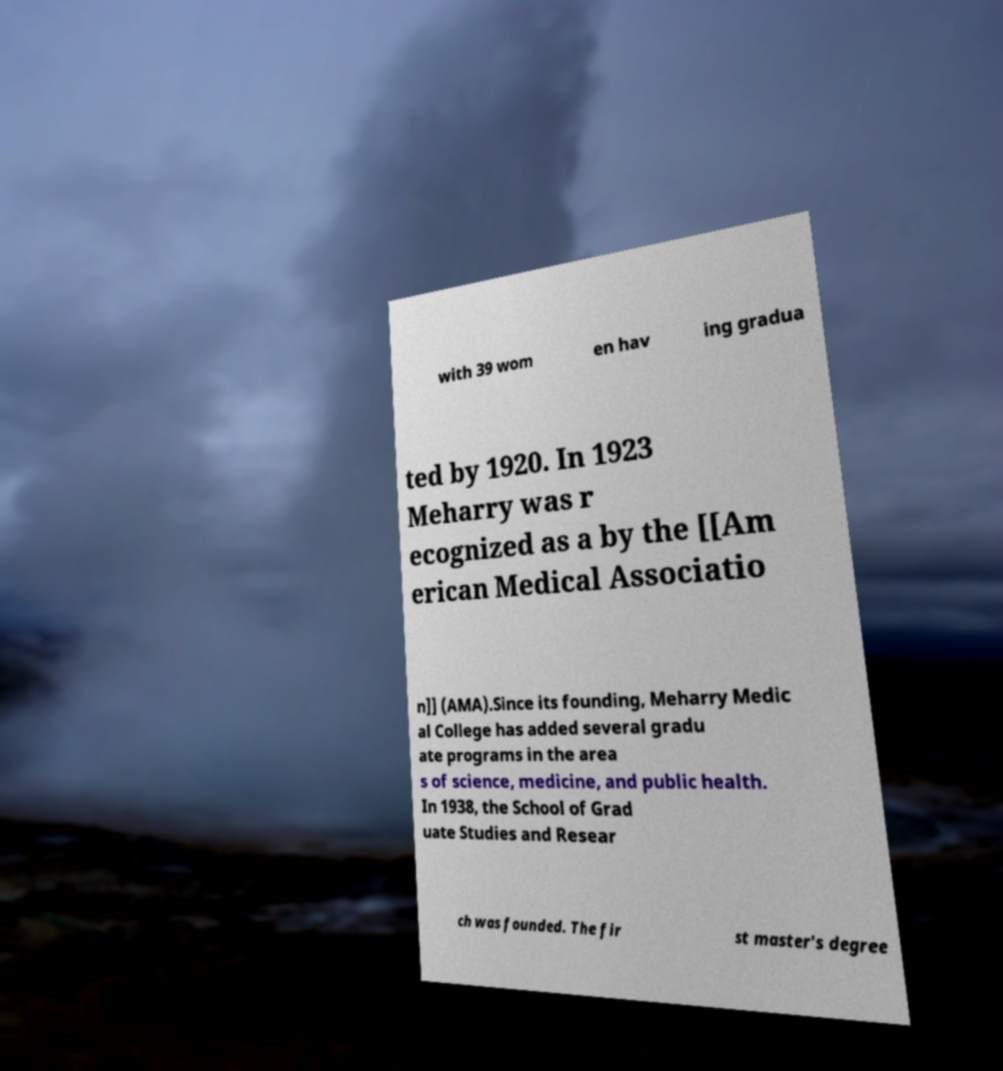Could you extract and type out the text from this image? with 39 wom en hav ing gradua ted by 1920. In 1923 Meharry was r ecognized as a by the [[Am erican Medical Associatio n]] (AMA).Since its founding, Meharry Medic al College has added several gradu ate programs in the area s of science, medicine, and public health. In 1938, the School of Grad uate Studies and Resear ch was founded. The fir st master's degree 